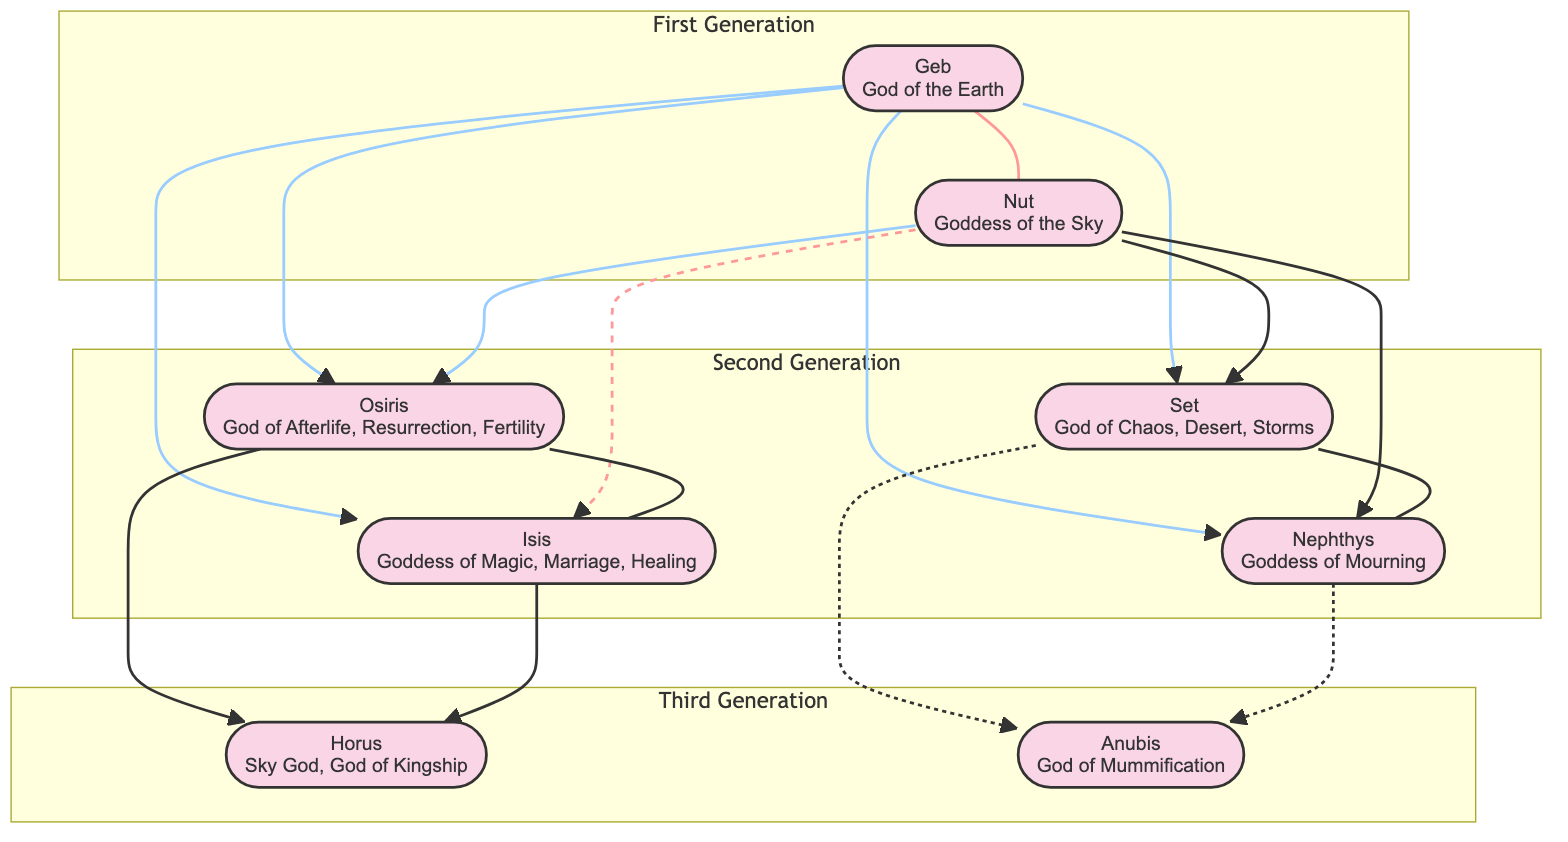What is the role of Horus? The diagram clearly states that Horus is the "Sky God, God of Kingship" in his node.
Answer: Sky God, God of Kingship Who are the parents of Osiris? By looking at the relationships defined for Osiris, it lists "Geb" and "Nut" as his parents.
Answer: Geb, Nut How many children do Osiris and Isis have? Referring to the relationships listed for both Osiris and Isis, we see that they have one child, Horus.
Answer: 1 Which deity is the spouse of Set? The relationships section for Set shows that his spouse is Nephthys.
Answer: Nephthys Who are the siblings of Isis? In the node for Isis, there is a reference to "siblings," which includes Osiris, Set, and Nephthys.
Answer: Osiris, Set, Nephthys How many generations of deities are represented in the diagram? The diagram is structured into three distinct groups or generations, clearly separating them into the first, second, and third generations.
Answer: 3 What is the relationship between Geb and Nut? The diagram shows a direct connection labeled as a spouse relationship between Geb and Nut.
Answer: Spouses Which deity is considered the God of Mummification? In the node for Anubis, it specifies that he is the "God of Mummification and the Afterlife."
Answer: God of Mummification Who are Horus's parents? By examining Horus's relationships, it lists Osiris and Isis as his parents.
Answer: Osiris, Isis 